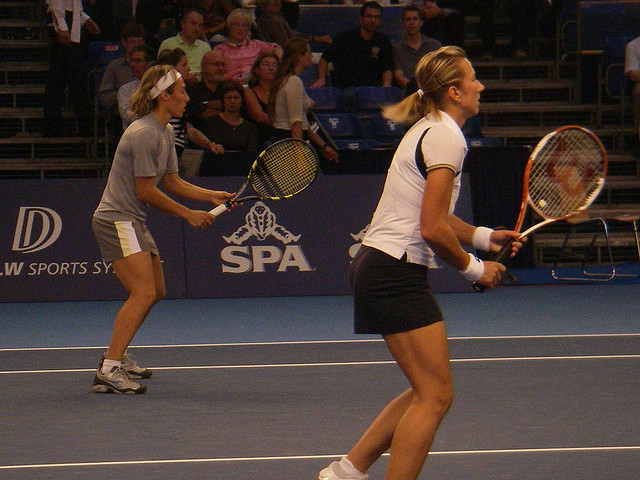What is the atmosphere of the event? The atmosphere appears competitive yet focused, typical of a professional tennis match. The audience, while not numerous, seems attentive, and the venue has the branding of a sports sponsor, indicating an organized event. 